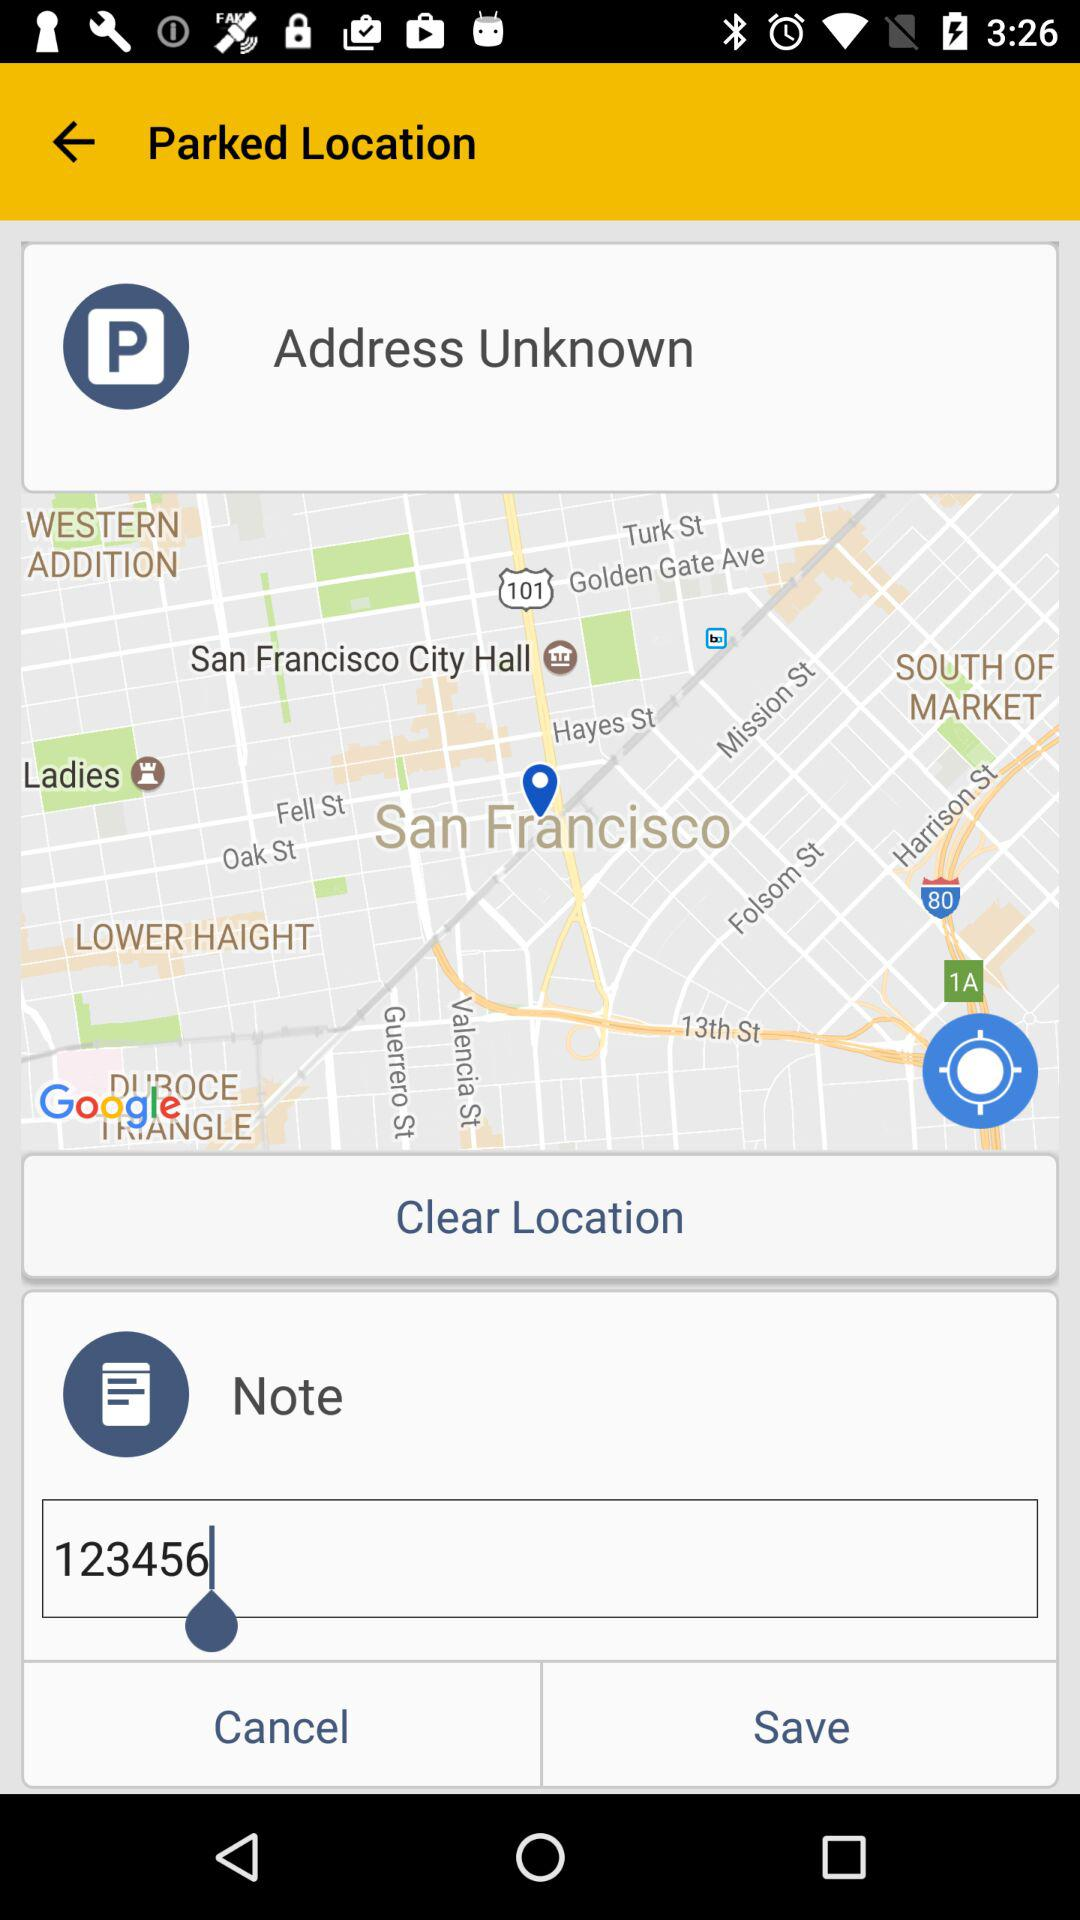What value is entered into the note text bar? The value entered is 123456. 